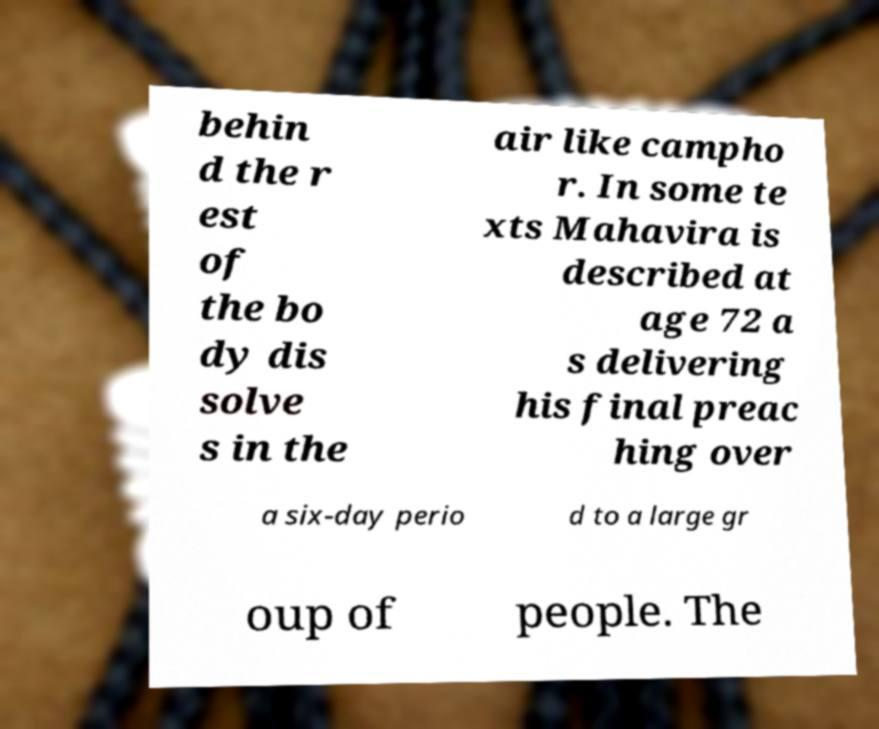There's text embedded in this image that I need extracted. Can you transcribe it verbatim? behin d the r est of the bo dy dis solve s in the air like campho r. In some te xts Mahavira is described at age 72 a s delivering his final preac hing over a six-day perio d to a large gr oup of people. The 